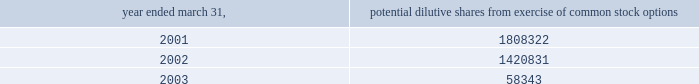( i ) intellectual property the company capitalizes as intellectual property costs incurred , excluding costs associated with company personnel , relating to patenting its technology .
Capitalized costs , the majority of which represent legal costs , reflect the cost of both awarded patents and patents pending .
The company amortizes the cost of these patents on a straight-line basis over a period of seven years .
If the company elects to stop pursuing a particular patent application or determines that a patent application is not likely to be awarded for a particular patent or elects to discontinue payment of required maintenance fees for a particular patent , the company at that time records as expense the net capitalized amount of such patent application or patent .
The company does not capitalize maintenance fees for patents .
( j ) net loss per share basic net loss per share is computed by dividing net loss by the weighted-average number of common shares outstanding during the fiscal year .
Diluted net loss per share is computed by dividing net loss by the weighted-average number of dilutive common shares outstanding during the fiscal year .
Diluted weighted-average shares reflect the dilutive effect , if any , of potential common stock such as options and warrants based on the treasury stock method .
No potential common stock is considered dilutive in periods in which a loss is reported , such as the fiscal years ended march 31 , 2001 , 2002 and 2003 , because all such common equivalent shares would be antidilutive .
The calculation of diluted weighted-average shares outstanding for the years ended march 31 , 2001 , 2002 and 2003 excludes the options to purchase common stock as shown below .
Potential dilutive shares year ended march 31 , from exercise of common stock options .
The calculation of diluted weighted-average shares outstanding excludes unissued shares of common stock associated with outstanding stock options that have exercise prices greater than the average market price of abiomed common stock during the period .
For the fiscal years ending march 31 , 2001 , 2002 and 2003 , the weighted-average number of these potential shares totaled 61661 , 341495 and 2463715 shares , respectively .
The calculation of diluted weighted-average shares outstanding for the years ended march 31 , 2001 , 2002 and 2003 also excludes warrants to purchase 400000 shares of common stock issued in connection with the acquisition of intellectual property ( see note 4 ) .
( k ) cash and cash equivalents the company classifies any marketable security with a maturity date of 90 days or less at the time of purchase as a cash equivalent .
( l ) marketable securities the company classifies any security with a maturity date of greater than 90 days at the time of purchase as marketable securities and classifies marketable securities with a maturity date of greater than one year from the balance sheet date as long-term investments .
Under statement of financial accounting standards ( sfas ) no .
115 , accounting for certain investments in debt and equity securities , securities that the company has the positive intent and ability to hold to maturity are reported at amortized cost and classified as held-to-maturity securities .
The amortized cost and market value of marketable securities were approximately $ 25654000 and $ 25661000 at march 31 , 2002 , and $ 9877000 and $ 9858000 at march 31 , 2003 , respectively .
At march 31 , 2003 , these short-term investments consisted primarily of government securities .
( m ) disclosures about fair value of financial instruments as of march 31 , 2002 and 2003 , the company 2019s financial instruments were comprised of cash and cash equivalents , marketable securities , accounts receivable and accounts payable , the carrying amounts of which approximated fair market value .
( n ) comprehensive income sfas no .
130 , reporting comprehensive income , requires disclosure of all components of comprehensive income and loss on an annual and interim basis .
Comprehensive income and loss is defined as the change in equity of a business enterprise during a period from transactions and other events and circumstances from non-owner sources .
Other than the reported net loss , there were no components of comprehensive income or loss which require disclosure for the years ended march 31 , 2001 , 2002 and 2003 .
Notes to consolidated financial statements ( continued ) march 31 , 2003 page 20 .
What was the decrease in potential dilutive shares from 2002 to 2003 ? 
Computations: (1420831 - 58343)
Answer: 1362488.0. 